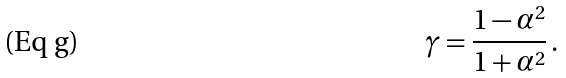<formula> <loc_0><loc_0><loc_500><loc_500>\gamma = \frac { 1 - \alpha ^ { 2 } } { 1 + \alpha ^ { 2 } } \, .</formula> 